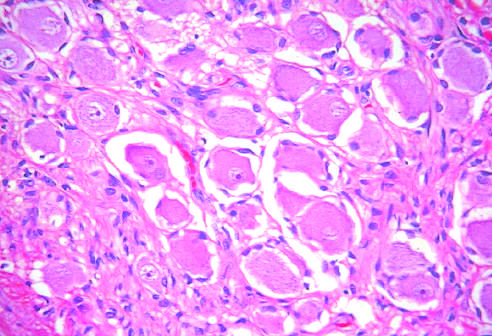what do testicular teratomas contain?
Answer the question using a single word or phrase. Mature cells from endodermal 